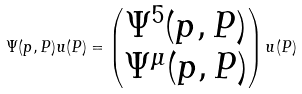Convert formula to latex. <formula><loc_0><loc_0><loc_500><loc_500>\Psi ( p , P ) u ( P ) = \begin{pmatrix} \Psi ^ { 5 } ( p , P ) \\ \Psi ^ { \mu } ( p , P ) \end{pmatrix} u ( P )</formula> 